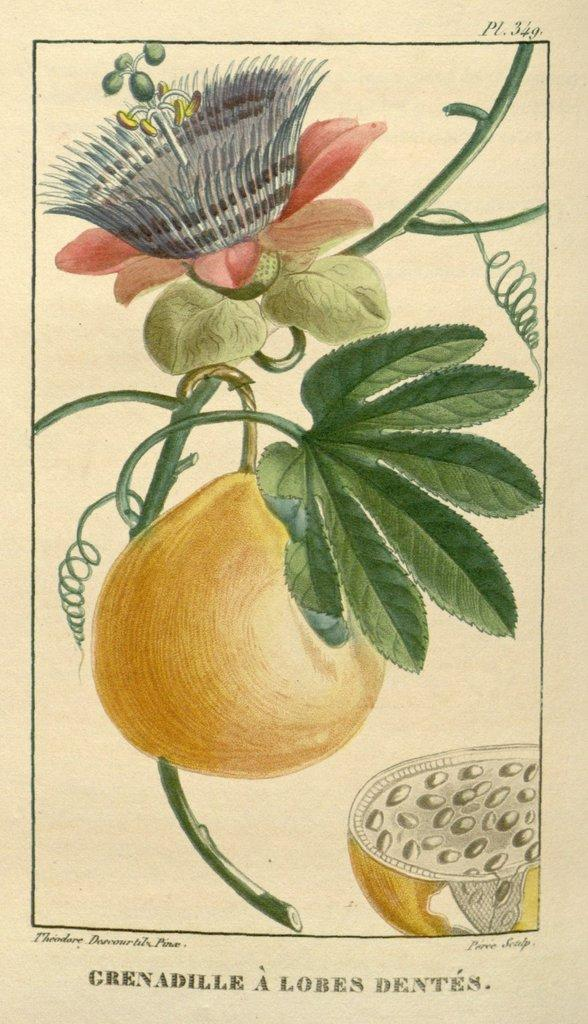What is the medium of the artwork in the image? The image is a painting on a paper. What types of objects are depicted in the painting? There are fruits, a leaf, and a flower in the image. Is there any text included in the painting? Yes, there is text at the bottom of the image. How many eyes can be seen on the fruit in the image? There are no eyes depicted on the fruit in the image, as fruits do not have eyes. 